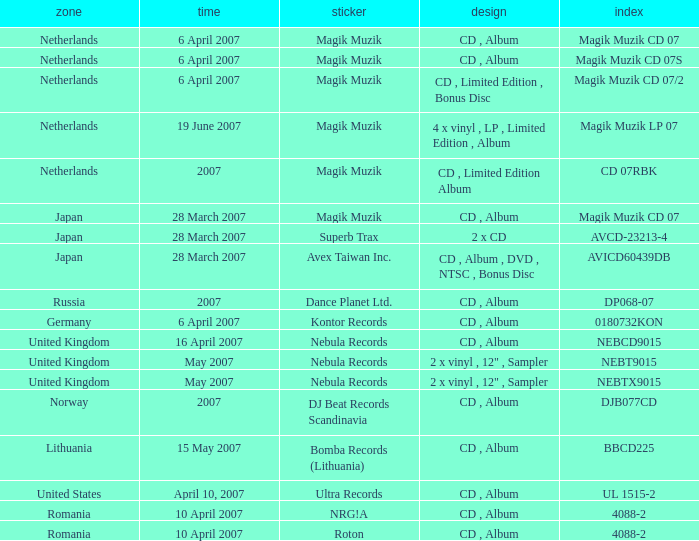For the catalog title DP068-07, what formats are available? CD , Album. I'm looking to parse the entire table for insights. Could you assist me with that? {'header': ['zone', 'time', 'sticker', 'design', 'index'], 'rows': [['Netherlands', '6 April 2007', 'Magik Muzik', 'CD , Album', 'Magik Muzik CD 07'], ['Netherlands', '6 April 2007', 'Magik Muzik', 'CD , Album', 'Magik Muzik CD 07S'], ['Netherlands', '6 April 2007', 'Magik Muzik', 'CD , Limited Edition , Bonus Disc', 'Magik Muzik CD 07/2'], ['Netherlands', '19 June 2007', 'Magik Muzik', '4 x vinyl , LP , Limited Edition , Album', 'Magik Muzik LP 07'], ['Netherlands', '2007', 'Magik Muzik', 'CD , Limited Edition Album', 'CD 07RBK'], ['Japan', '28 March 2007', 'Magik Muzik', 'CD , Album', 'Magik Muzik CD 07'], ['Japan', '28 March 2007', 'Superb Trax', '2 x CD', 'AVCD-23213-4'], ['Japan', '28 March 2007', 'Avex Taiwan Inc.', 'CD , Album , DVD , NTSC , Bonus Disc', 'AVICD60439DB'], ['Russia', '2007', 'Dance Planet Ltd.', 'CD , Album', 'DP068-07'], ['Germany', '6 April 2007', 'Kontor Records', 'CD , Album', '0180732KON'], ['United Kingdom', '16 April 2007', 'Nebula Records', 'CD , Album', 'NEBCD9015'], ['United Kingdom', 'May 2007', 'Nebula Records', '2 x vinyl , 12" , Sampler', 'NEBT9015'], ['United Kingdom', 'May 2007', 'Nebula Records', '2 x vinyl , 12" , Sampler', 'NEBTX9015'], ['Norway', '2007', 'DJ Beat Records Scandinavia', 'CD , Album', 'DJB077CD'], ['Lithuania', '15 May 2007', 'Bomba Records (Lithuania)', 'CD , Album', 'BBCD225'], ['United States', 'April 10, 2007', 'Ultra Records', 'CD , Album', 'UL 1515-2'], ['Romania', '10 April 2007', 'NRG!A', 'CD , Album', '4088-2'], ['Romania', '10 April 2007', 'Roton', 'CD , Album', '4088-2']]} 